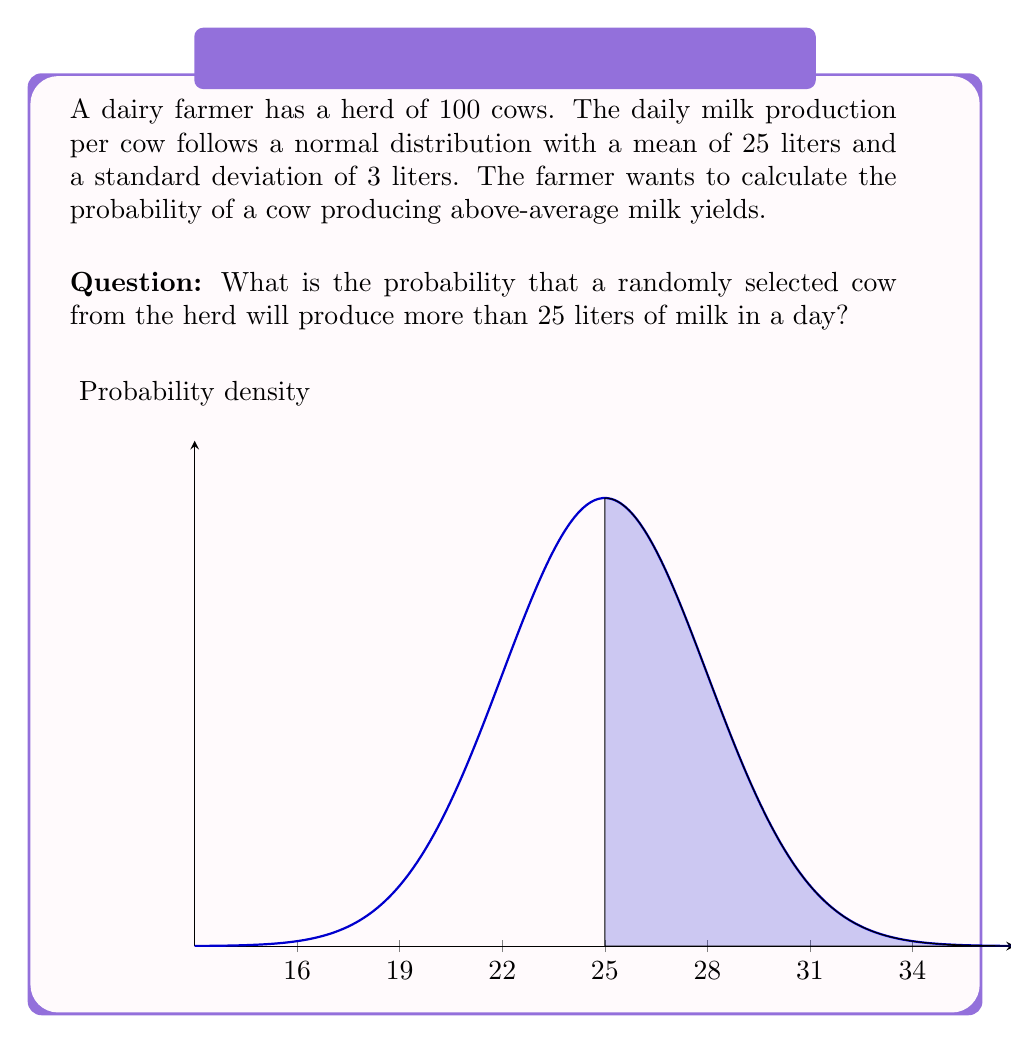Could you help me with this problem? Let's approach this step-by-step:

1) We are given that the milk production follows a normal distribution with:
   $\mu = 25$ liters (mean)
   $\sigma = 3$ liters (standard deviation)

2) We want to find $P(X > 25)$, where $X$ is the milk production of a randomly selected cow.

3) In a normal distribution, exactly 50% of the data falls below the mean, and 50% falls above the mean.

4) Since we're asked about the probability of producing more than 25 liters (which is the mean), the answer is simply:

   $P(X > 25) = 0.5$ or $50\%$

5) We can verify this using the standard normal distribution:
   $Z = \frac{X - \mu}{\sigma} = \frac{25 - 25}{3} = 0$

   $P(X > 25) = P(Z > 0) = 0.5$

This result makes intuitive sense: in a symmetrical distribution like the normal distribution, half of the cows will produce above average, and half will produce below average.
Answer: 0.5 or 50% 